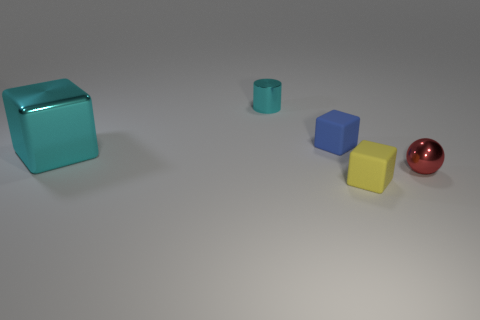What number of other things are the same color as the small ball?
Offer a very short reply. 0. Is there anything else that has the same size as the cyan metal cube?
Give a very brief answer. No. There is a object that is in front of the tiny red thing; is its shape the same as the rubber thing that is behind the big object?
Offer a terse response. Yes. What is the shape of the blue matte object that is the same size as the cylinder?
Give a very brief answer. Cube. Are there the same number of yellow rubber things to the right of the metallic ball and big shiny objects that are on the left side of the yellow object?
Offer a terse response. No. Are there any other things that have the same shape as the yellow object?
Your response must be concise. Yes. Do the thing that is behind the blue cube and the yellow object have the same material?
Keep it short and to the point. No. What material is the cyan cylinder that is the same size as the yellow matte thing?
Offer a terse response. Metal. What number of other objects are the same material as the cyan cylinder?
Keep it short and to the point. 2. There is a ball; is it the same size as the rubber cube that is in front of the small shiny sphere?
Give a very brief answer. Yes. 